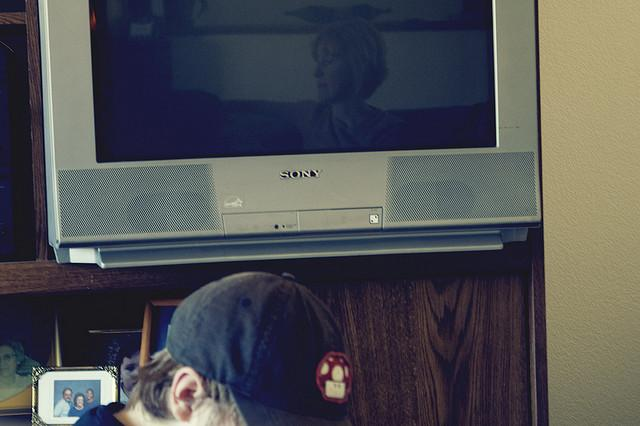When did the TV company start using this name? Please explain your reasoning. 1958. This was 12 years after the company was founded 